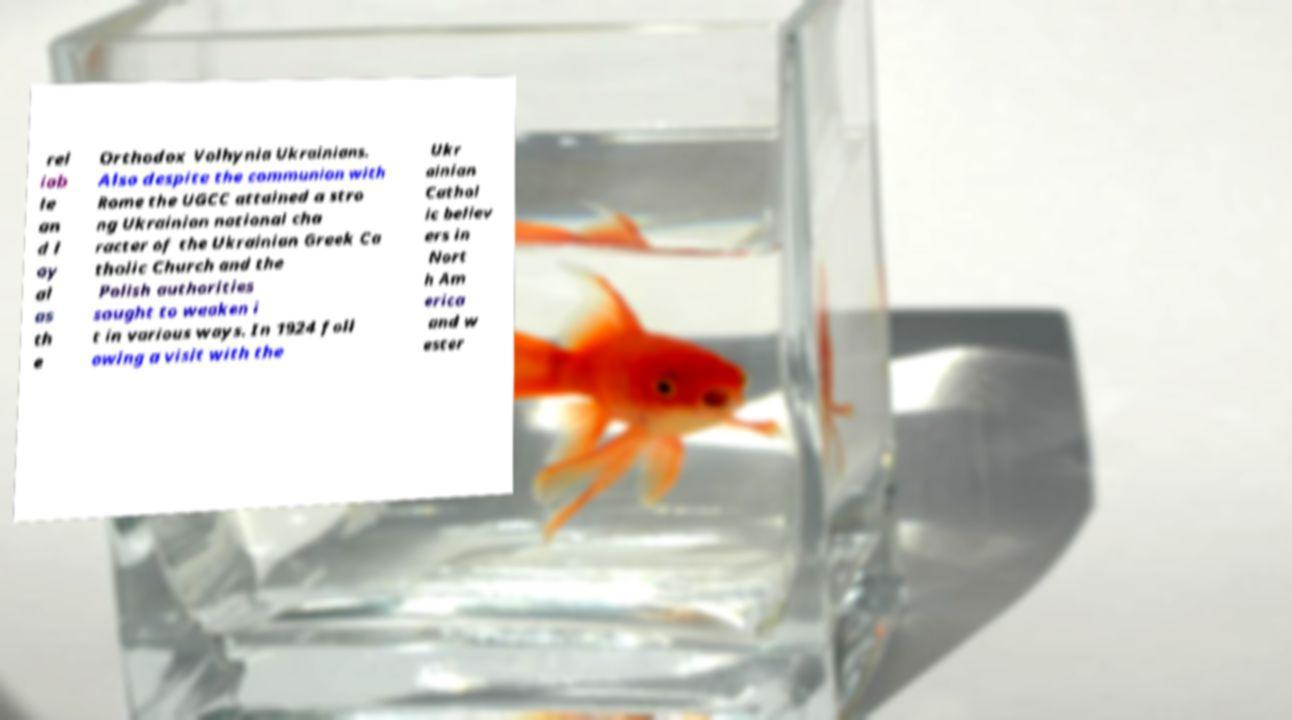Can you accurately transcribe the text from the provided image for me? rel iab le an d l oy al as th e Orthodox Volhynia Ukrainians. Also despite the communion with Rome the UGCC attained a stro ng Ukrainian national cha racter of the Ukrainian Greek Ca tholic Church and the Polish authorities sought to weaken i t in various ways. In 1924 foll owing a visit with the Ukr ainian Cathol ic believ ers in Nort h Am erica and w ester 